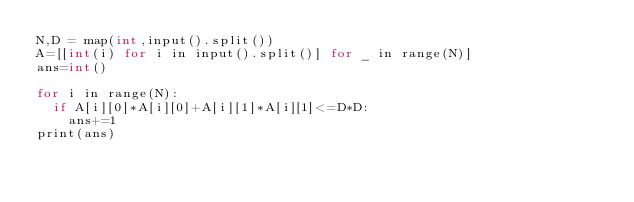<code> <loc_0><loc_0><loc_500><loc_500><_C++_>N,D = map(int,input().split())
A=[[int(i) for i in input().split()] for _ in range(N)]
ans=int()

for i in range(N):
  if A[i][0]*A[i][0]+A[i][1]*A[i][1]<=D*D:
    ans+=1
print(ans)
  
</code> 